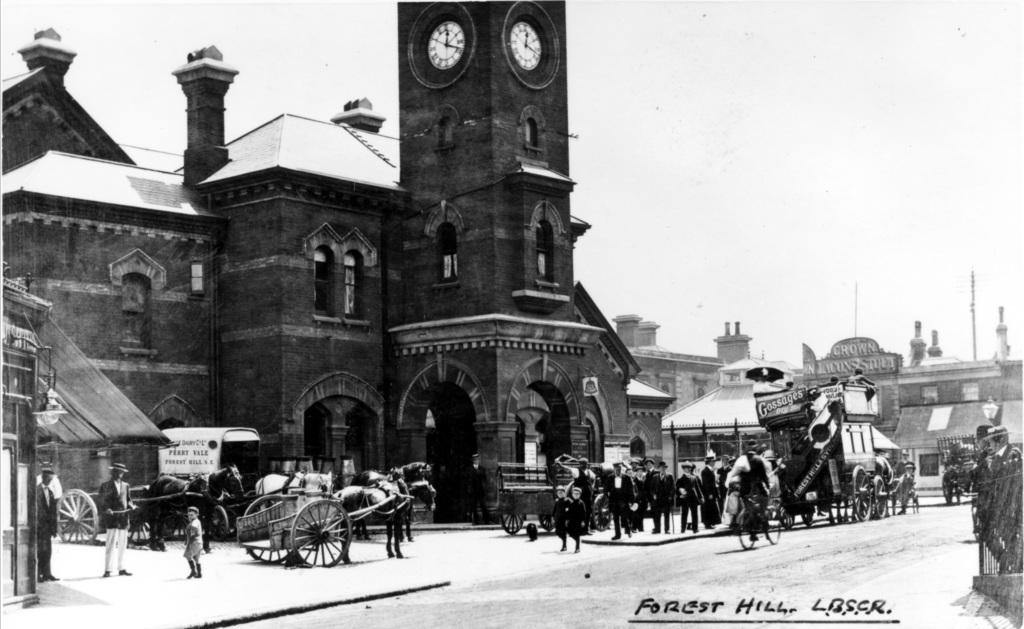What is the color scheme of the image? The image is black and white. What can be seen in the image besides the color scheme? There is a building and horse carts on the left side of the image, as well as people walking on the right side of the image. Where are the people walking in the image? The people are walking on a road in the image. What type of appliance can be seen in the image? There is no appliance present in the image. What muscle is being flexed by the people walking in the image? There is no indication of any specific muscle being flexed by the people walking in the image. 